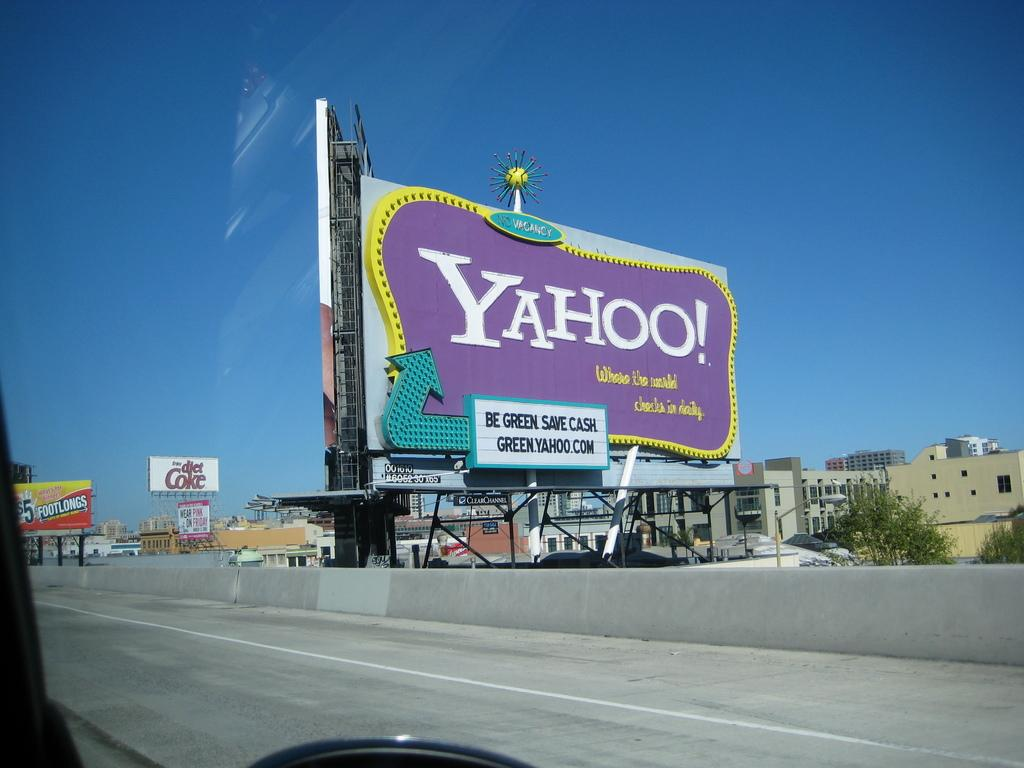<image>
Summarize the visual content of the image. A large billboard that states be green save cash. 